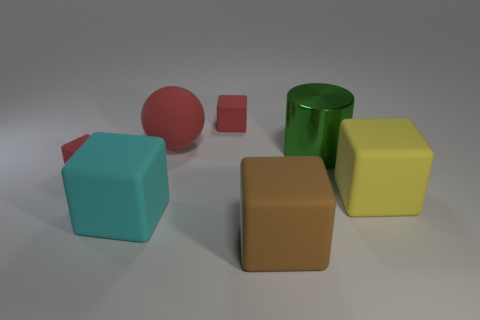Are there any tiny matte objects that have the same color as the big matte ball?
Make the answer very short. Yes. Are the block to the right of the big brown object and the tiny red block that is on the right side of the cyan rubber cube made of the same material?
Offer a very short reply. Yes. The cyan block in front of the tiny thing that is behind the shiny object is made of what material?
Your answer should be compact. Rubber. What is the red object that is right of the matte sphere made of?
Provide a short and direct response. Rubber. How many tiny red matte things have the same shape as the big brown matte thing?
Provide a short and direct response. 2. Is the color of the rubber ball the same as the metallic cylinder?
Ensure brevity in your answer.  No. What material is the small cube right of the large matte thing behind the matte thing that is to the right of the cylinder?
Give a very brief answer. Rubber. There is a yellow matte object; are there any big yellow cubes right of it?
Ensure brevity in your answer.  No. There is a red matte thing that is the same size as the brown matte object; what is its shape?
Make the answer very short. Sphere. Is the brown thing made of the same material as the large green cylinder?
Offer a very short reply. No. 